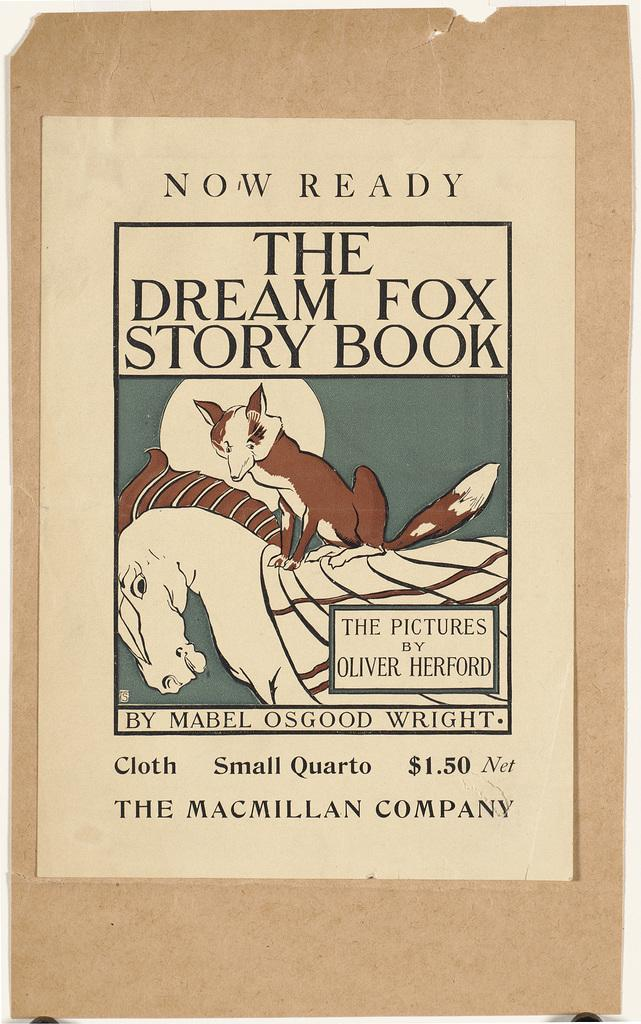What is present in the image? There is a paper in the image. What can be found on the paper? The paper contains text and images of animals. How does the beggar in the image ask for soup? There is no beggar or soup present in the image; it only contains a paper with text and images of animals. 